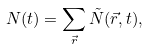<formula> <loc_0><loc_0><loc_500><loc_500>N ( t ) = \sum _ { \vec { r } } \tilde { N } ( \vec { r } , t ) ,</formula> 